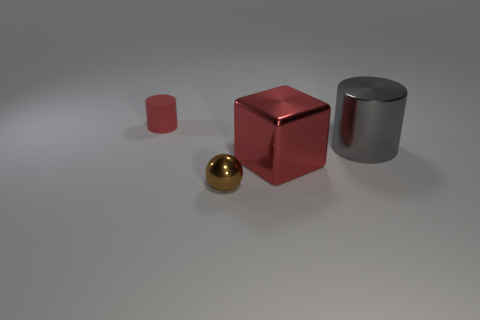Is there any other thing that is the same color as the tiny metal ball? Upon reviewing the image, it appears that there are no other objects that match the exact hue of the tiny metal ball, which has a distinct golden color. The other objects in the image — the cube, cylinder, and smaller cuboid — each have their own unique colors, ranging from a glossy silver for the cylinder to varying shades of red for the two other shapes. 